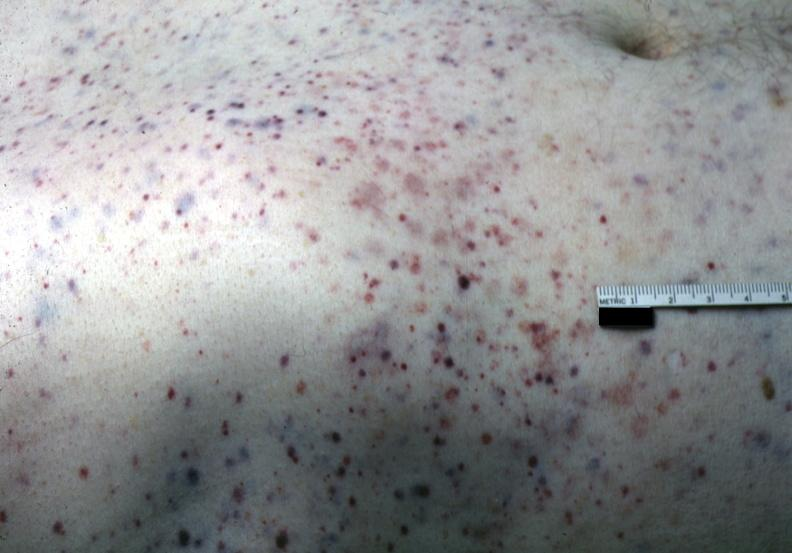how does this image show white skin?
Answer the question using a single word or phrase. With multiple lesions 